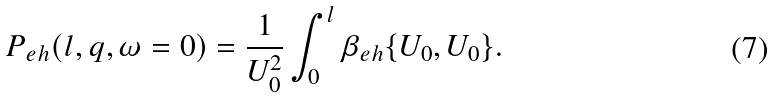<formula> <loc_0><loc_0><loc_500><loc_500>P _ { e h } ( l , { q } , \omega = 0 ) = \frac { 1 } { U _ { 0 } ^ { 2 } } \int _ { 0 } ^ { l } \beta _ { e h } \{ U _ { 0 } , U _ { 0 } \} .</formula> 